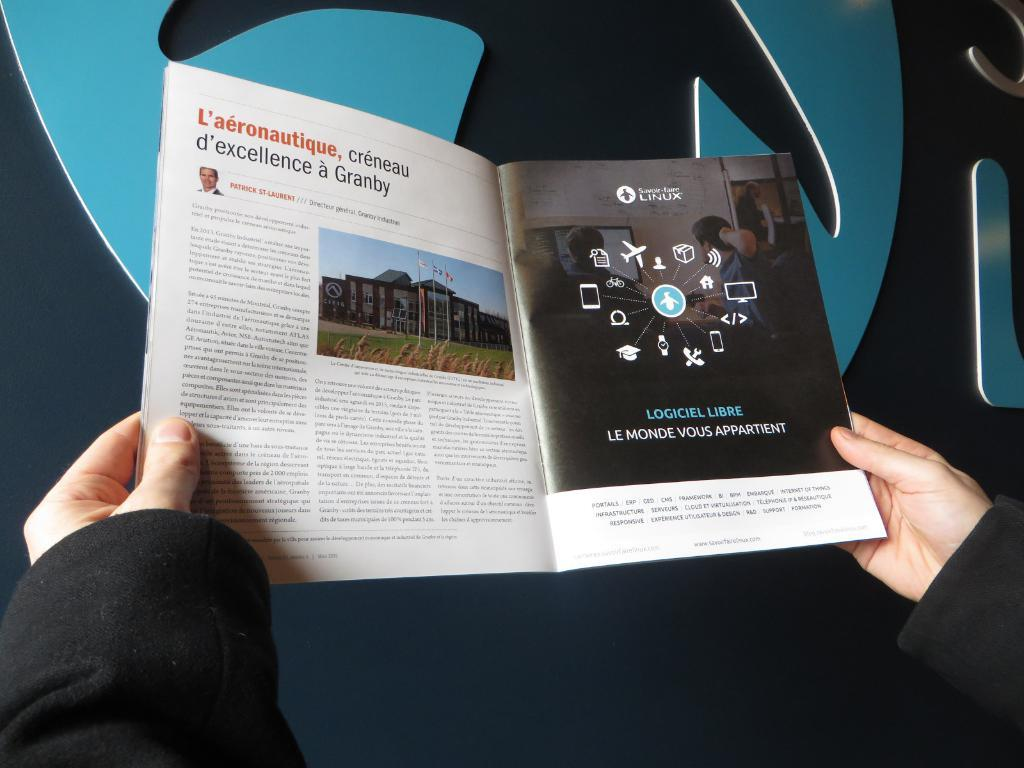<image>
Summarize the visual content of the image. Someone is reading a magazine in French with an ad next to it. 